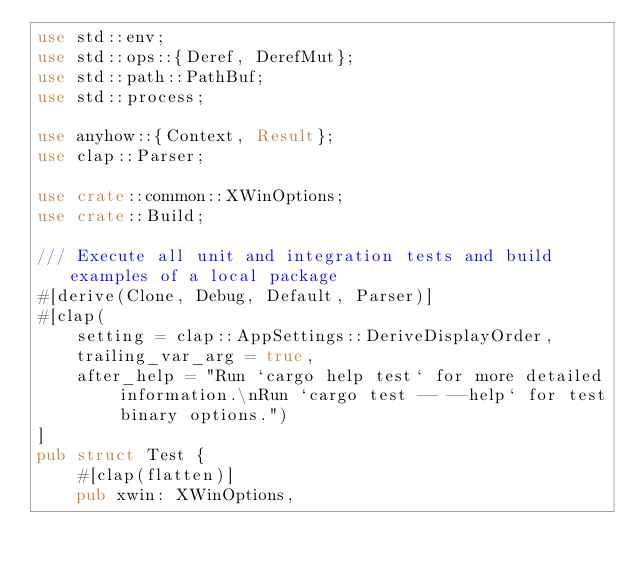<code> <loc_0><loc_0><loc_500><loc_500><_Rust_>use std::env;
use std::ops::{Deref, DerefMut};
use std::path::PathBuf;
use std::process;

use anyhow::{Context, Result};
use clap::Parser;

use crate::common::XWinOptions;
use crate::Build;

/// Execute all unit and integration tests and build examples of a local package
#[derive(Clone, Debug, Default, Parser)]
#[clap(
    setting = clap::AppSettings::DeriveDisplayOrder,
    trailing_var_arg = true,
    after_help = "Run `cargo help test` for more detailed information.\nRun `cargo test -- --help` for test binary options.")
]
pub struct Test {
    #[clap(flatten)]
    pub xwin: XWinOptions,
</code> 